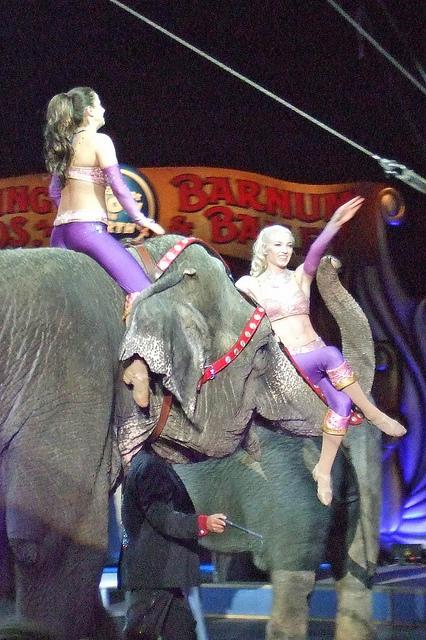IS the man holding anything?
Write a very short answer. Yes. What event is this a photo of?
Be succinct. Circus. How many elephants do you see?
Short answer required. 2. 